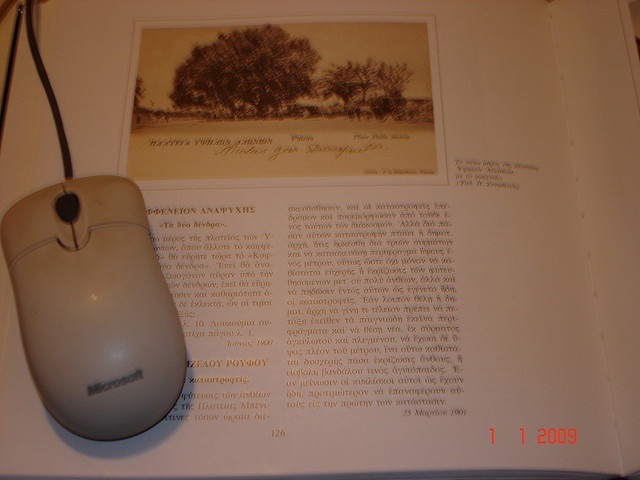Describe the objects in this image and their specific colors. I can see book in gray and brown tones and mouse in maroon, gray, brown, and black tones in this image. 